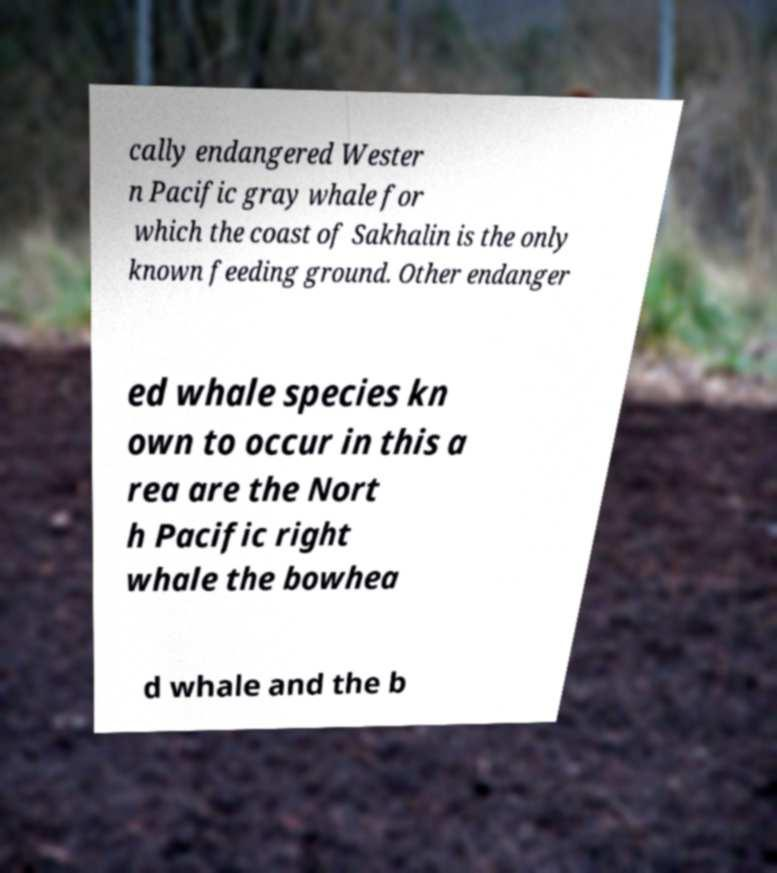For documentation purposes, I need the text within this image transcribed. Could you provide that? cally endangered Wester n Pacific gray whale for which the coast of Sakhalin is the only known feeding ground. Other endanger ed whale species kn own to occur in this a rea are the Nort h Pacific right whale the bowhea d whale and the b 